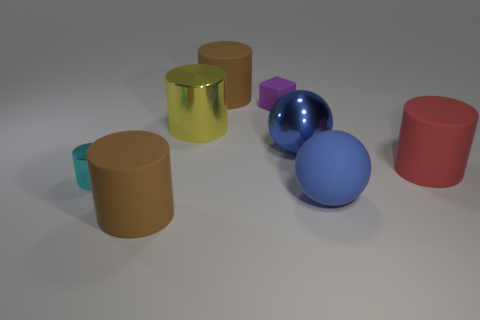Subtract all yellow cylinders. How many cylinders are left? 4 Subtract all tiny cyan cylinders. How many cylinders are left? 4 Subtract all gray cylinders. Subtract all gray cubes. How many cylinders are left? 5 Add 1 red rubber objects. How many objects exist? 9 Subtract all cylinders. How many objects are left? 3 Add 2 brown rubber objects. How many brown rubber objects exist? 4 Subtract 0 brown balls. How many objects are left? 8 Subtract all large blue objects. Subtract all purple rubber blocks. How many objects are left? 5 Add 5 small purple objects. How many small purple objects are left? 6 